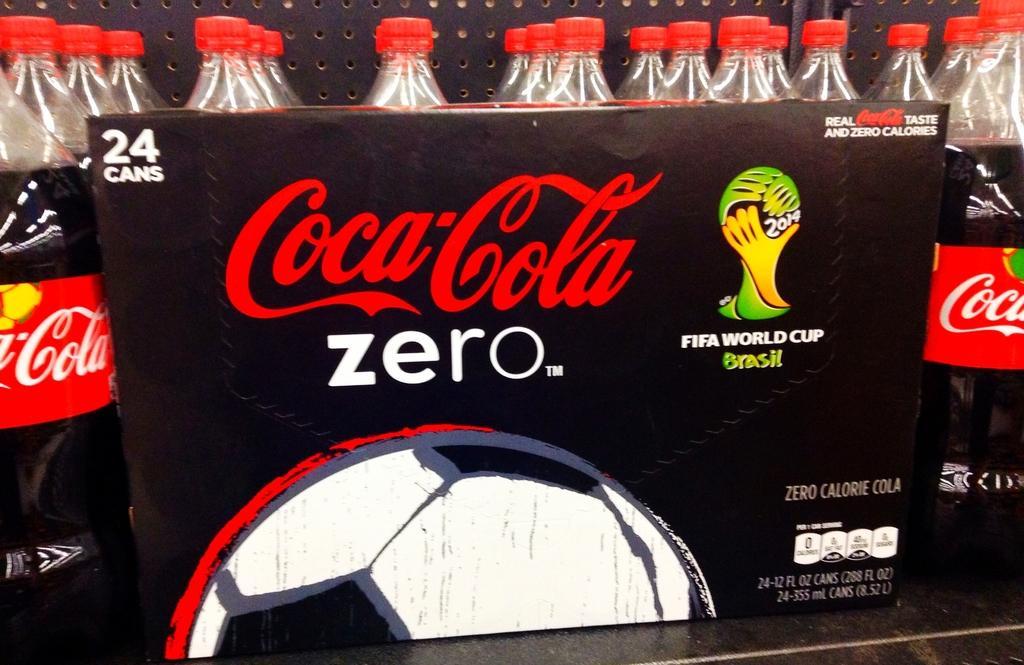How would you summarize this image in a sentence or two? In this picture I can observe some drink bottles placed in the rack. I can observe black color board in front of the bottles. There is some text on this board. 